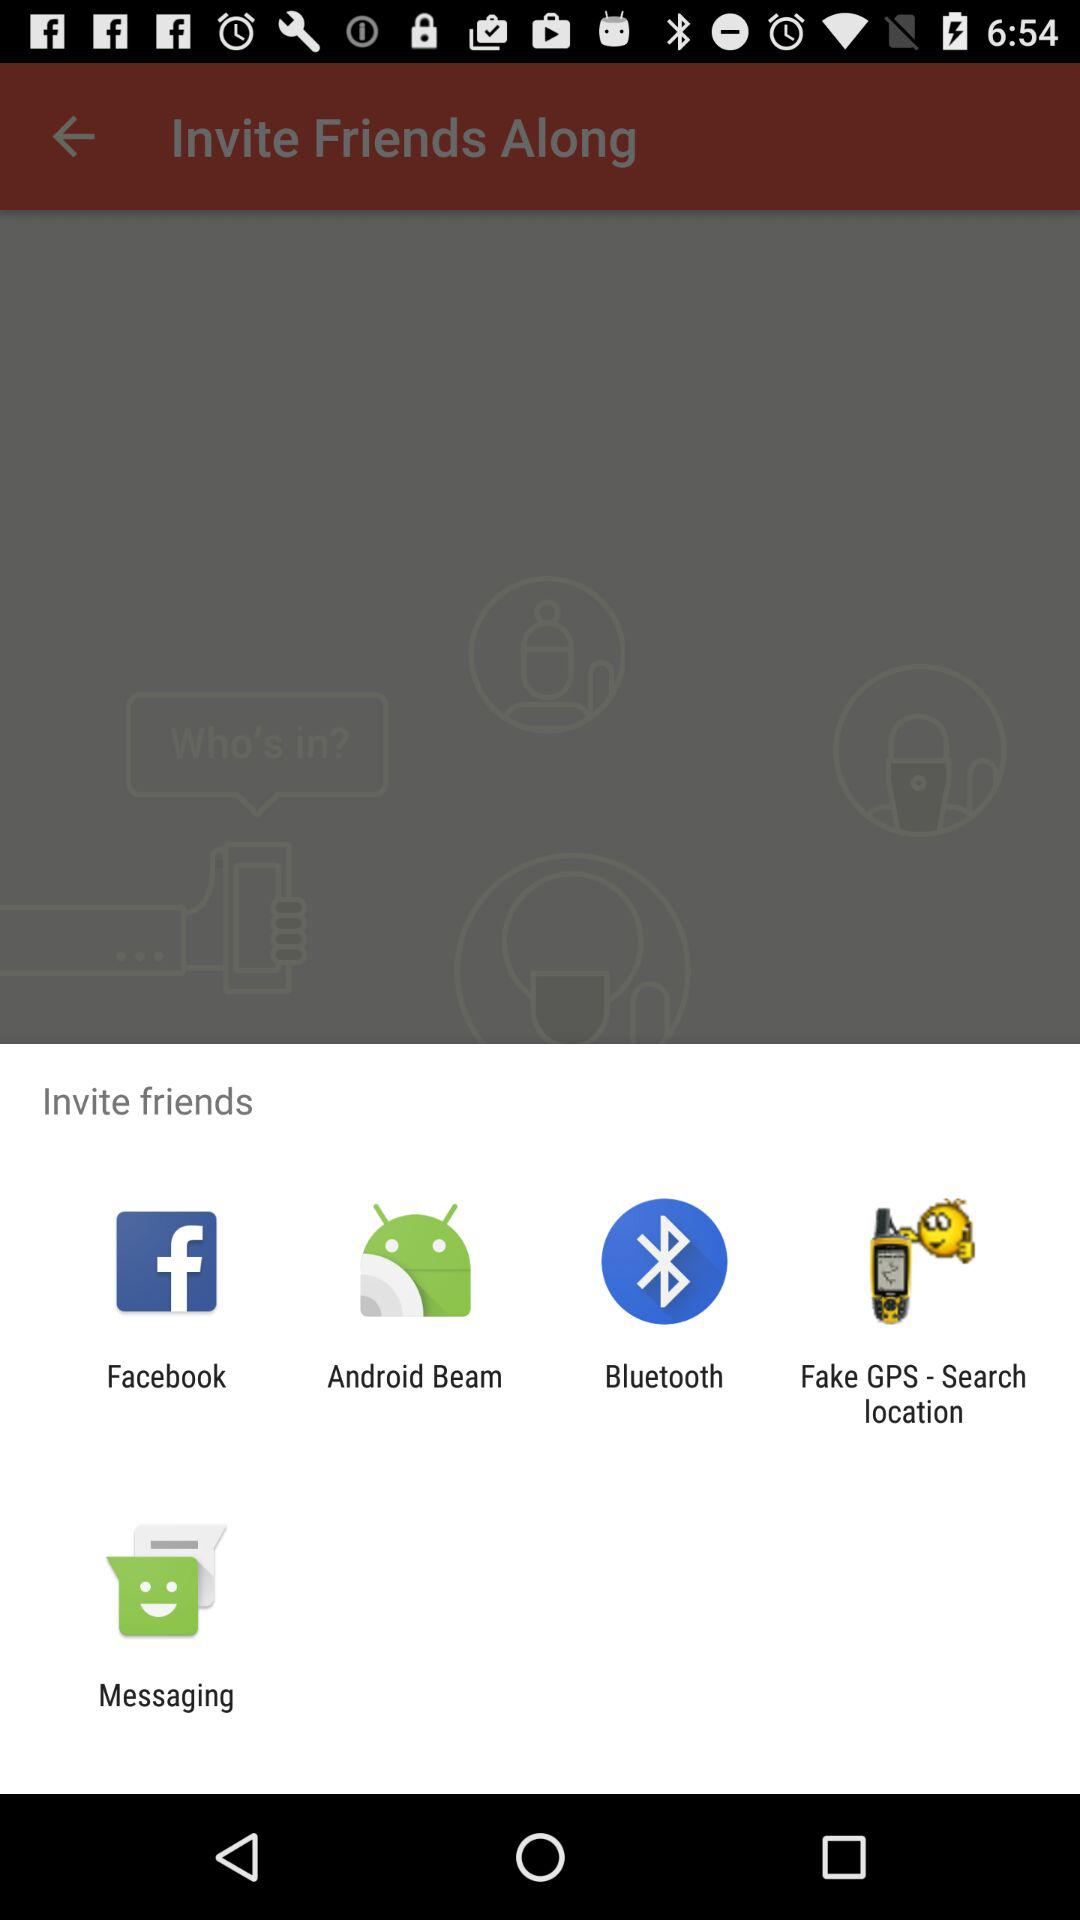What are the options to invite friends? The options to invite friends are "Facebook", "Android Beam", "Bluetooth", "Fake GPS - Search location" and "Messaging". 